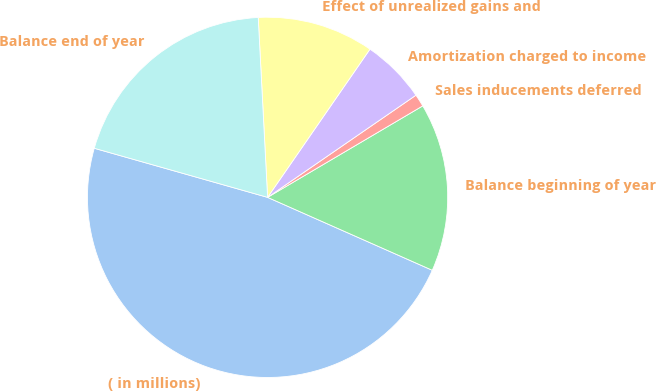Convert chart to OTSL. <chart><loc_0><loc_0><loc_500><loc_500><pie_chart><fcel>( in millions)<fcel>Balance beginning of year<fcel>Sales inducements deferred<fcel>Amortization charged to income<fcel>Effect of unrealized gains and<fcel>Balance end of year<nl><fcel>47.76%<fcel>15.11%<fcel>1.12%<fcel>5.78%<fcel>10.45%<fcel>19.78%<nl></chart> 